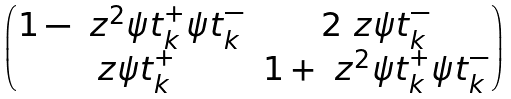<formula> <loc_0><loc_0><loc_500><loc_500>\begin{pmatrix} 1 - \ z ^ { 2 } \psi t ^ { + } _ { k } \psi t ^ { - } _ { k } & 2 \ z \psi t ^ { - } _ { k } \\ \ z \psi t ^ { + } _ { k } & 1 + \ z ^ { 2 } \psi t ^ { + } _ { k } \psi t ^ { - } _ { k } \end{pmatrix}</formula> 